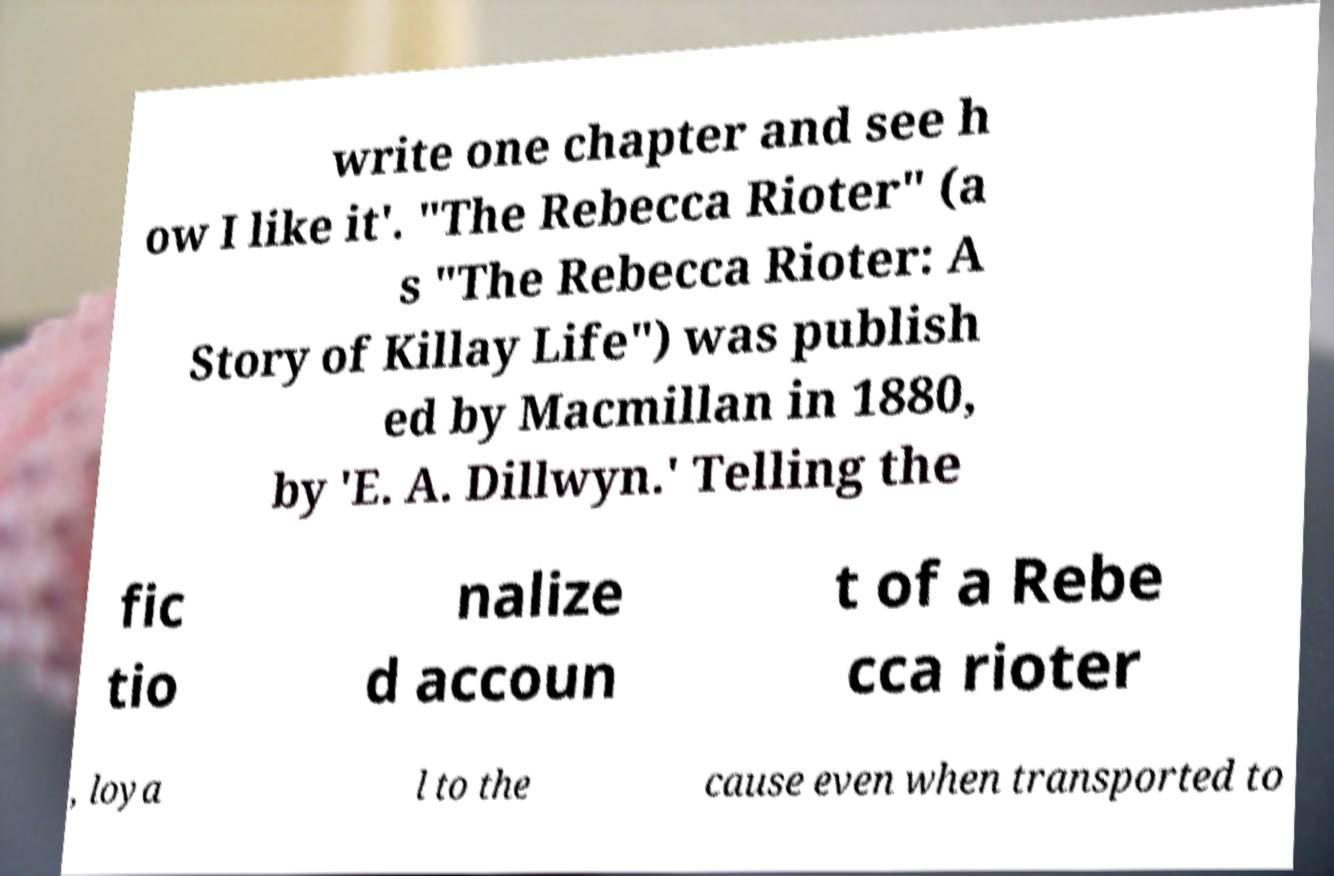Can you accurately transcribe the text from the provided image for me? write one chapter and see h ow I like it'. "The Rebecca Rioter" (a s "The Rebecca Rioter: A Story of Killay Life") was publish ed by Macmillan in 1880, by 'E. A. Dillwyn.' Telling the fic tio nalize d accoun t of a Rebe cca rioter , loya l to the cause even when transported to 